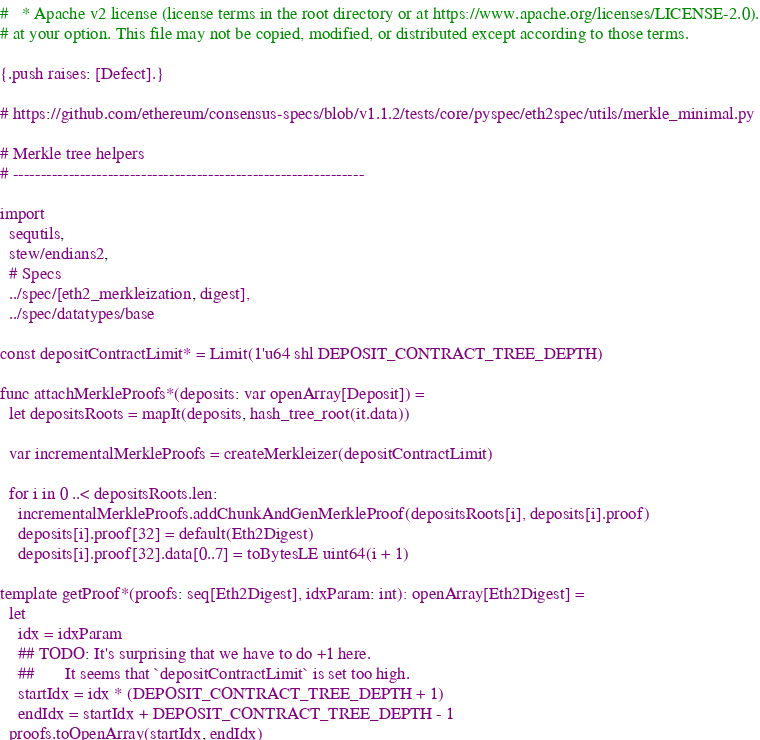<code> <loc_0><loc_0><loc_500><loc_500><_Nim_>#   * Apache v2 license (license terms in the root directory or at https://www.apache.org/licenses/LICENSE-2.0).
# at your option. This file may not be copied, modified, or distributed except according to those terms.

{.push raises: [Defect].}

# https://github.com/ethereum/consensus-specs/blob/v1.1.2/tests/core/pyspec/eth2spec/utils/merkle_minimal.py

# Merkle tree helpers
# ---------------------------------------------------------------

import
  sequtils,
  stew/endians2,
  # Specs
  ../spec/[eth2_merkleization, digest],
  ../spec/datatypes/base

const depositContractLimit* = Limit(1'u64 shl DEPOSIT_CONTRACT_TREE_DEPTH)

func attachMerkleProofs*(deposits: var openArray[Deposit]) =
  let depositsRoots = mapIt(deposits, hash_tree_root(it.data))

  var incrementalMerkleProofs = createMerkleizer(depositContractLimit)

  for i in 0 ..< depositsRoots.len:
    incrementalMerkleProofs.addChunkAndGenMerkleProof(depositsRoots[i], deposits[i].proof)
    deposits[i].proof[32] = default(Eth2Digest)
    deposits[i].proof[32].data[0..7] = toBytesLE uint64(i + 1)

template getProof*(proofs: seq[Eth2Digest], idxParam: int): openArray[Eth2Digest] =
  let
    idx = idxParam
    ## TODO: It's surprising that we have to do +1 here.
    ##       It seems that `depositContractLimit` is set too high.
    startIdx = idx * (DEPOSIT_CONTRACT_TREE_DEPTH + 1)
    endIdx = startIdx + DEPOSIT_CONTRACT_TREE_DEPTH - 1
  proofs.toOpenArray(startIdx, endIdx)

</code> 